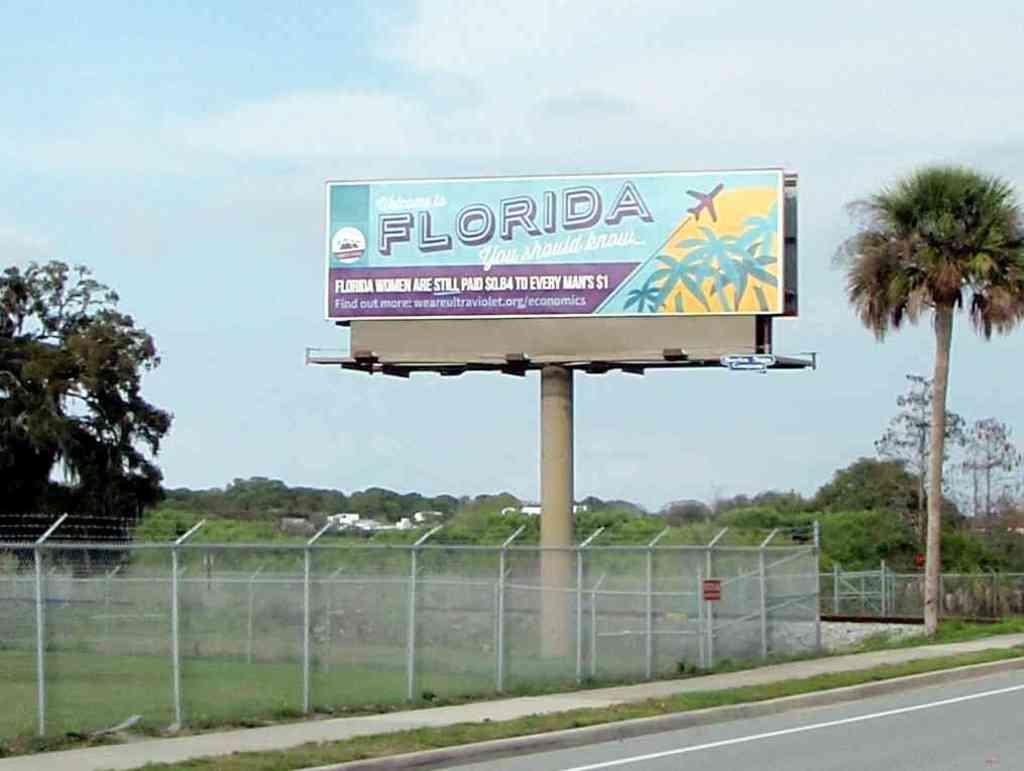<image>
Give a short and clear explanation of the subsequent image. A Florida billboard bemoans women's lack of equal pay compared to men. 